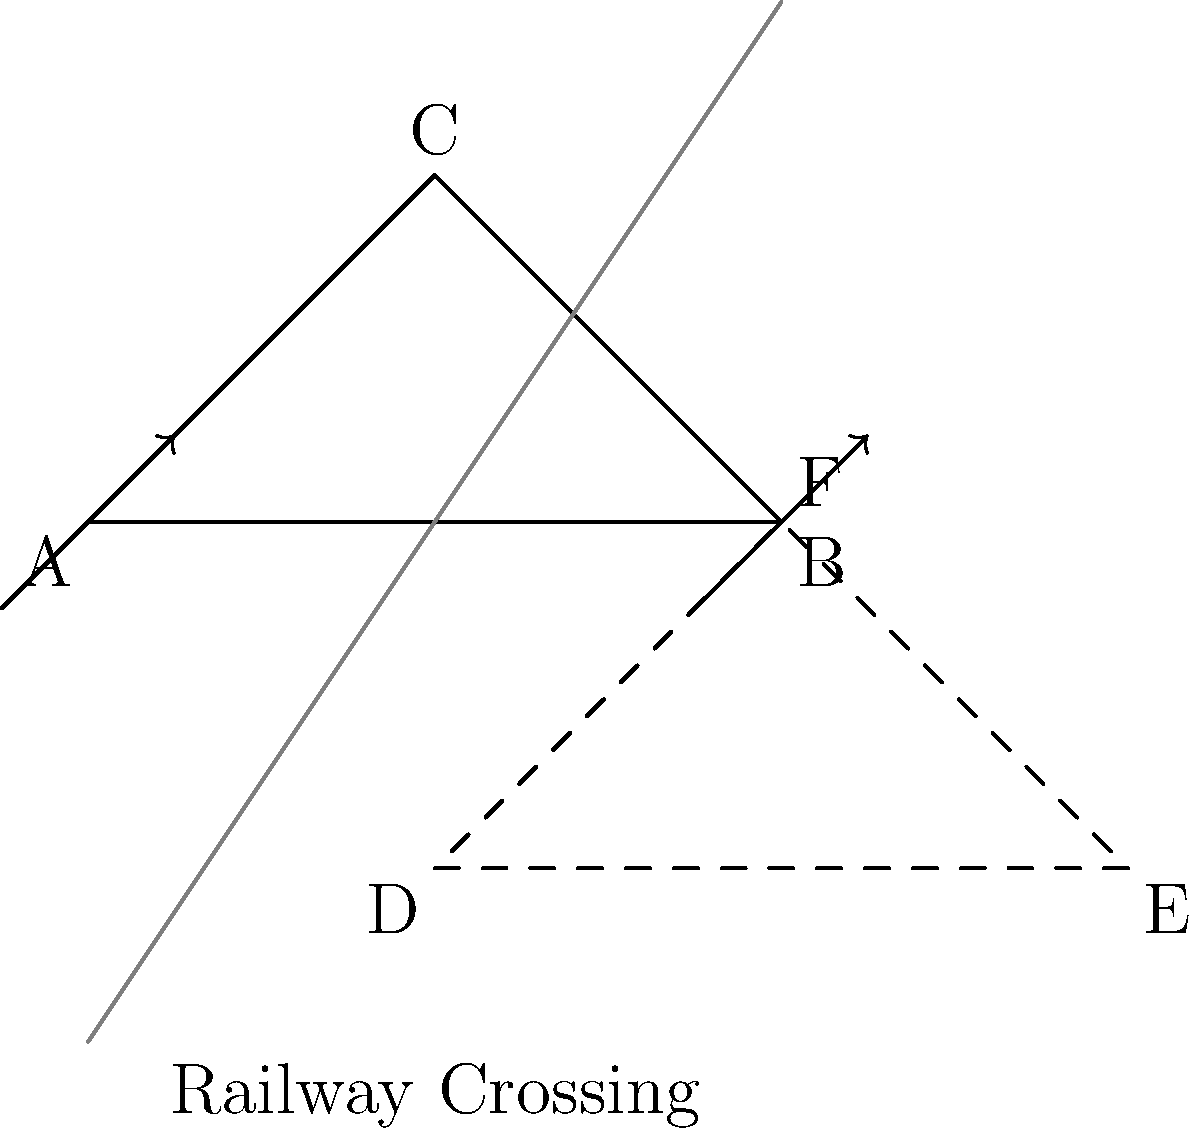A railway crossing sign is represented by triangle ABC. If this sign is reflected across the gray line, what are the coordinates of point E in the reflected image? To find the coordinates of point E in the reflected image, we need to follow these steps:

1) First, identify the line of reflection. In this case, it's the gray line passing through points (0,-3) and (4,3).

2) The equation of this line can be derived:
   Slope = (3 - (-3)) / (4 - 0) = 3/2
   Using point-slope form: $y - (-3) = \frac{3}{2}(x - 0)$
   Simplified: $y = \frac{3}{2}x - 3$

3) Point B (4,0) is reflected to point E. To find E's coordinates:

   a) Find the perpendicular line to the reflection line passing through B:
      Slope of perpendicular line = $-\frac{2}{3}$
      Equation: $y - 0 = -\frac{2}{3}(x - 4)$

   b) Find the intersection of this perpendicular line with the reflection line:
      $\frac{3}{2}x - 3 = -\frac{2}{3}(x - 4)$
      Solving this: $x = 3$

   c) Substitute this x-value into either line equation to find y:
      $y = \frac{3}{2}(3) - 3 = 1.5$

4) The midpoint of BE is on the reflection line. We can use this to verify:
   Midpoint = $(\frac{4+3}{2}, \frac{0+1.5}{2}) = (3.5, 0.75)$
   This point satisfies the reflection line equation.

5) Therefore, point E is twice as far from the reflection line as B, in the opposite direction.
   E's x-coordinate: $4 - (3.5 - 4) = 4.5$
   E's y-coordinate: $0 - (0.75 - 0) = -0.75$

Thus, the coordinates of point E are (4.5, -0.75).
Answer: (4.5, -0.75) 